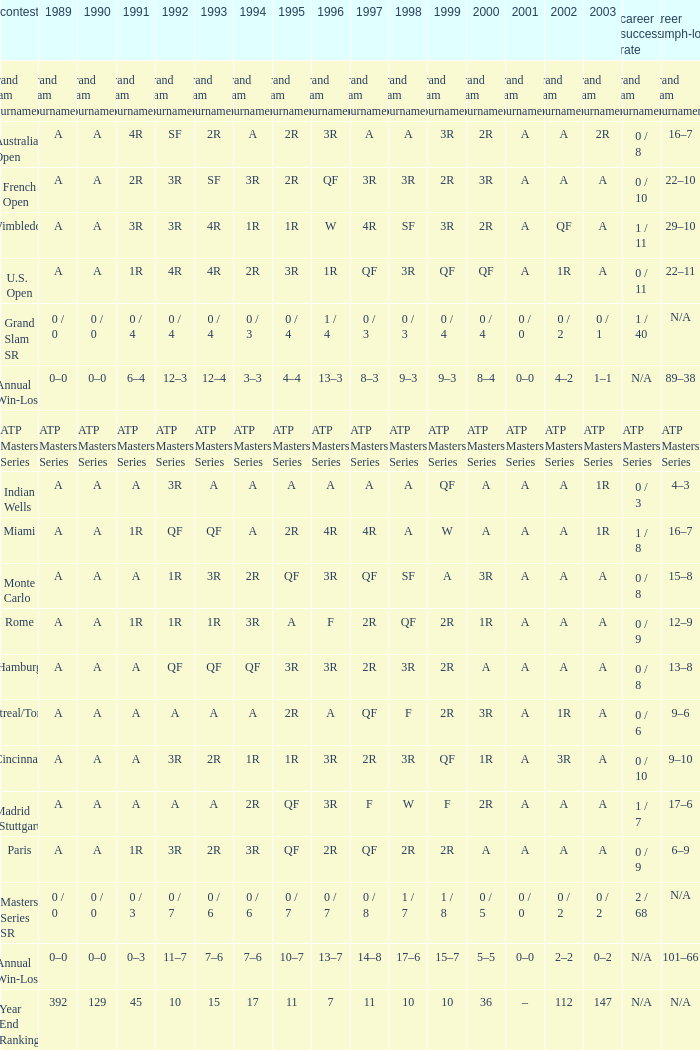What was the value in 1989 with QF in 1997 and A in 1993? A. 